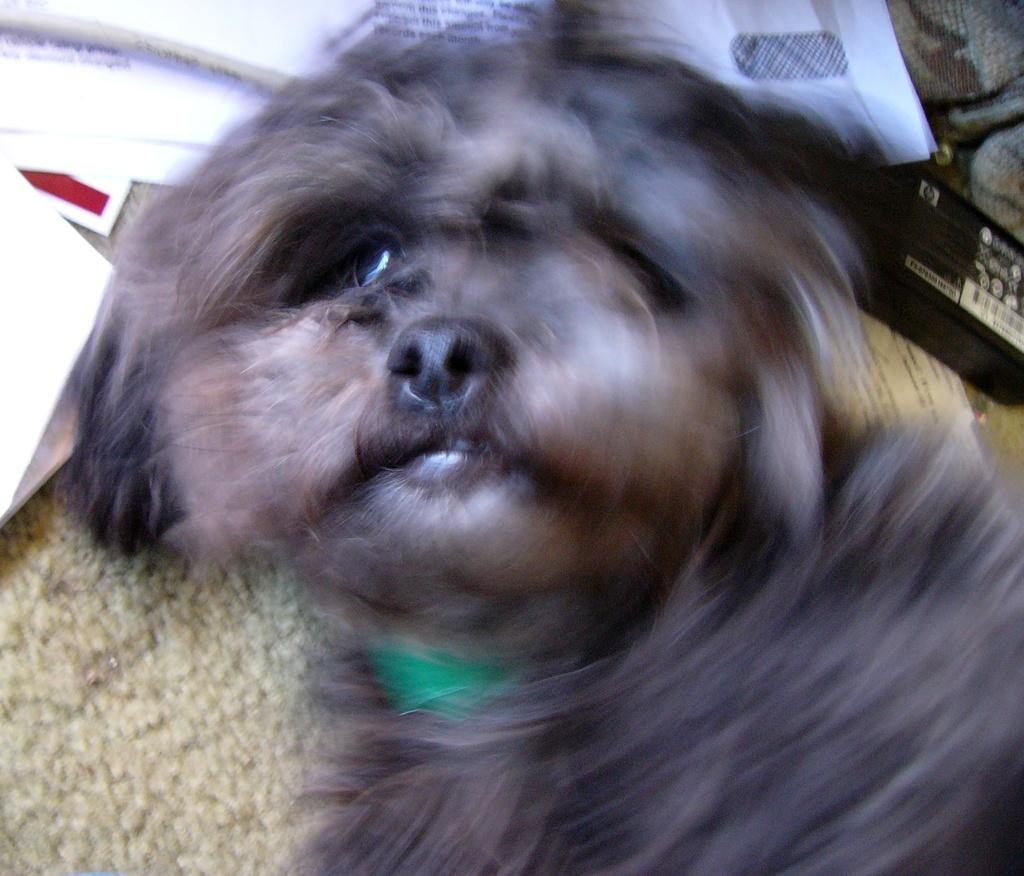What type of animal is in the picture? There is a dog in the picture. What color is the dog's fur? The dog has black fur. What else can be seen on the floor in the picture? There are papers on the floor. How many quarters can be seen on the dog's back in the image? There are no quarters present in the image, and the dog's back is not mentioned in the facts provided. 